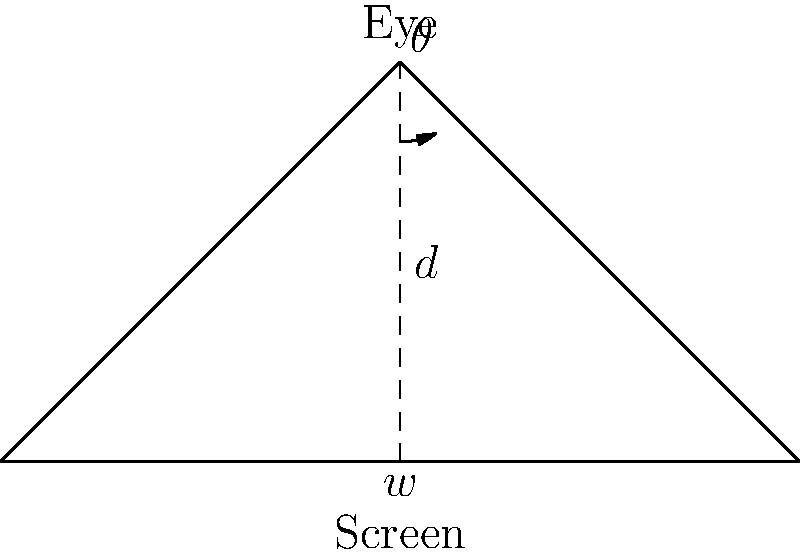You're setting up your new Alienware gaming laptop for optimal viewing. The screen width is 15 inches, and you want to maintain a 30° viewing angle for the best gaming experience. At what distance $d$ (in inches) should you position your eyes from the center of the screen? Round your answer to the nearest tenth of an inch. To solve this problem, we'll use trigonometry:

1) In the diagram, we have a right triangle where:
   - $w$ is half the screen width (as we're measuring from the center)
   - $d$ is the distance from eyes to screen
   - $\theta$ is half the viewing angle

2) The screen width is 15 inches, so $w = 15/2 = 7.5$ inches

3) We want a 30° viewing angle, so $\theta = 30°/2 = 15°$

4) In this right triangle, we can use the tangent function:

   $$\tan(\theta) = \frac{\text{opposite}}{\text{adjacent}} = \frac{w}{d}$$

5) Rearranging this equation:

   $$d = \frac{w}{\tan(\theta)}$$

6) Plugging in our values:

   $$d = \frac{7.5}{\tan(15°)}$$

7) Using a calculator:

   $$d \approx 28.0087 \text{ inches}$$

8) Rounding to the nearest tenth:

   $$d \approx 28.0 \text{ inches}$$
Answer: 28.0 inches 